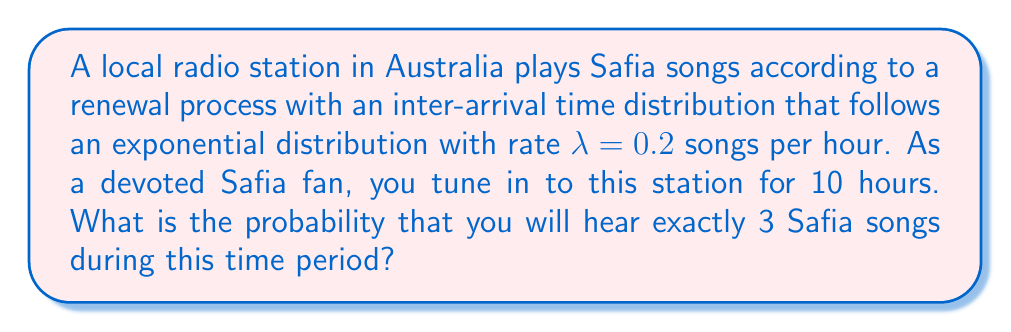Give your solution to this math problem. Let's approach this step-by-step:

1) The number of events (Safia songs played) in a fixed time interval for a renewal process with exponentially distributed inter-arrival times follows a Poisson distribution.

2) The parameter of this Poisson distribution is $\mu = \lambda t$, where $\lambda$ is the rate parameter of the exponential distribution and $t$ is the time interval.

3) In this case:
   $\lambda = 0.2$ songs/hour
   $t = 10$ hours
   $\mu = \lambda t = 0.2 \times 10 = 2$

4) The probability of exactly $k$ events in a Poisson process is given by:

   $$P(X = k) = \frac{e^{-\mu} \mu^k}{k!}$$

5) We want the probability of exactly 3 songs, so $k = 3$:

   $$P(X = 3) = \frac{e^{-2} 2^3}{3!}$$

6) Let's calculate this:
   
   $$P(X = 3) = \frac{e^{-2} \times 8}{6} = \frac{e^{-2} \times 4}{3}$$

7) Using a calculator:

   $$P(X = 3) \approx 0.1804$$

Thus, the probability of hearing exactly 3 Safia songs in 10 hours is approximately 0.1804 or 18.04%.
Answer: 0.1804 